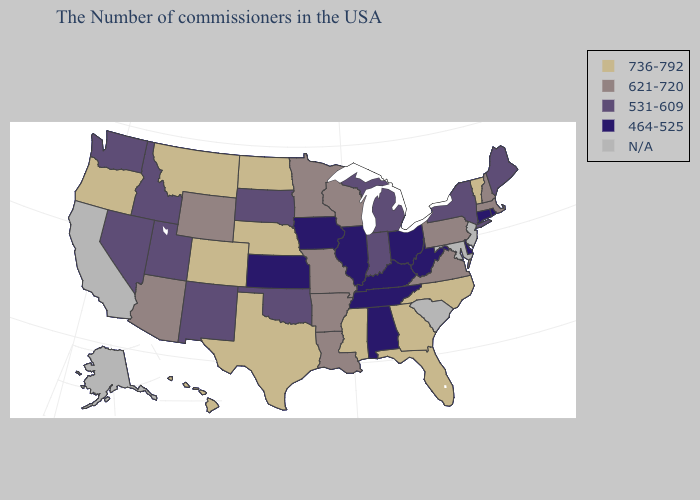What is the value of Utah?
Keep it brief. 531-609. Name the states that have a value in the range 621-720?
Keep it brief. Massachusetts, New Hampshire, Pennsylvania, Virginia, Wisconsin, Louisiana, Missouri, Arkansas, Minnesota, Wyoming, Arizona. Does Missouri have the lowest value in the MidWest?
Answer briefly. No. What is the lowest value in the USA?
Concise answer only. 464-525. Does the first symbol in the legend represent the smallest category?
Be succinct. No. What is the value of Kentucky?
Quick response, please. 464-525. Among the states that border Nebraska , which have the highest value?
Be succinct. Colorado. What is the lowest value in the Northeast?
Answer briefly. 464-525. What is the value of Louisiana?
Concise answer only. 621-720. What is the value of Tennessee?
Short answer required. 464-525. Name the states that have a value in the range 531-609?
Short answer required. Maine, New York, Michigan, Indiana, Oklahoma, South Dakota, New Mexico, Utah, Idaho, Nevada, Washington. Among the states that border Louisiana , does Arkansas have the lowest value?
Write a very short answer. Yes. 